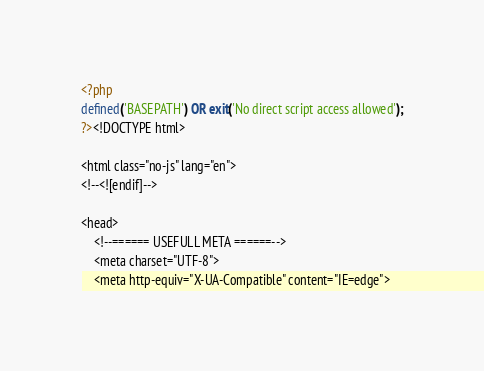Convert code to text. <code><loc_0><loc_0><loc_500><loc_500><_PHP_><?php
defined('BASEPATH') OR exit('No direct script access allowed');
?><!DOCTYPE html>

<html class="no-js" lang="en">
<!--<![endif]-->

<head>
    <!--====== USEFULL META ======-->
    <meta charset="UTF-8">
    <meta http-equiv="X-UA-Compatible" content="IE=edge"></code> 